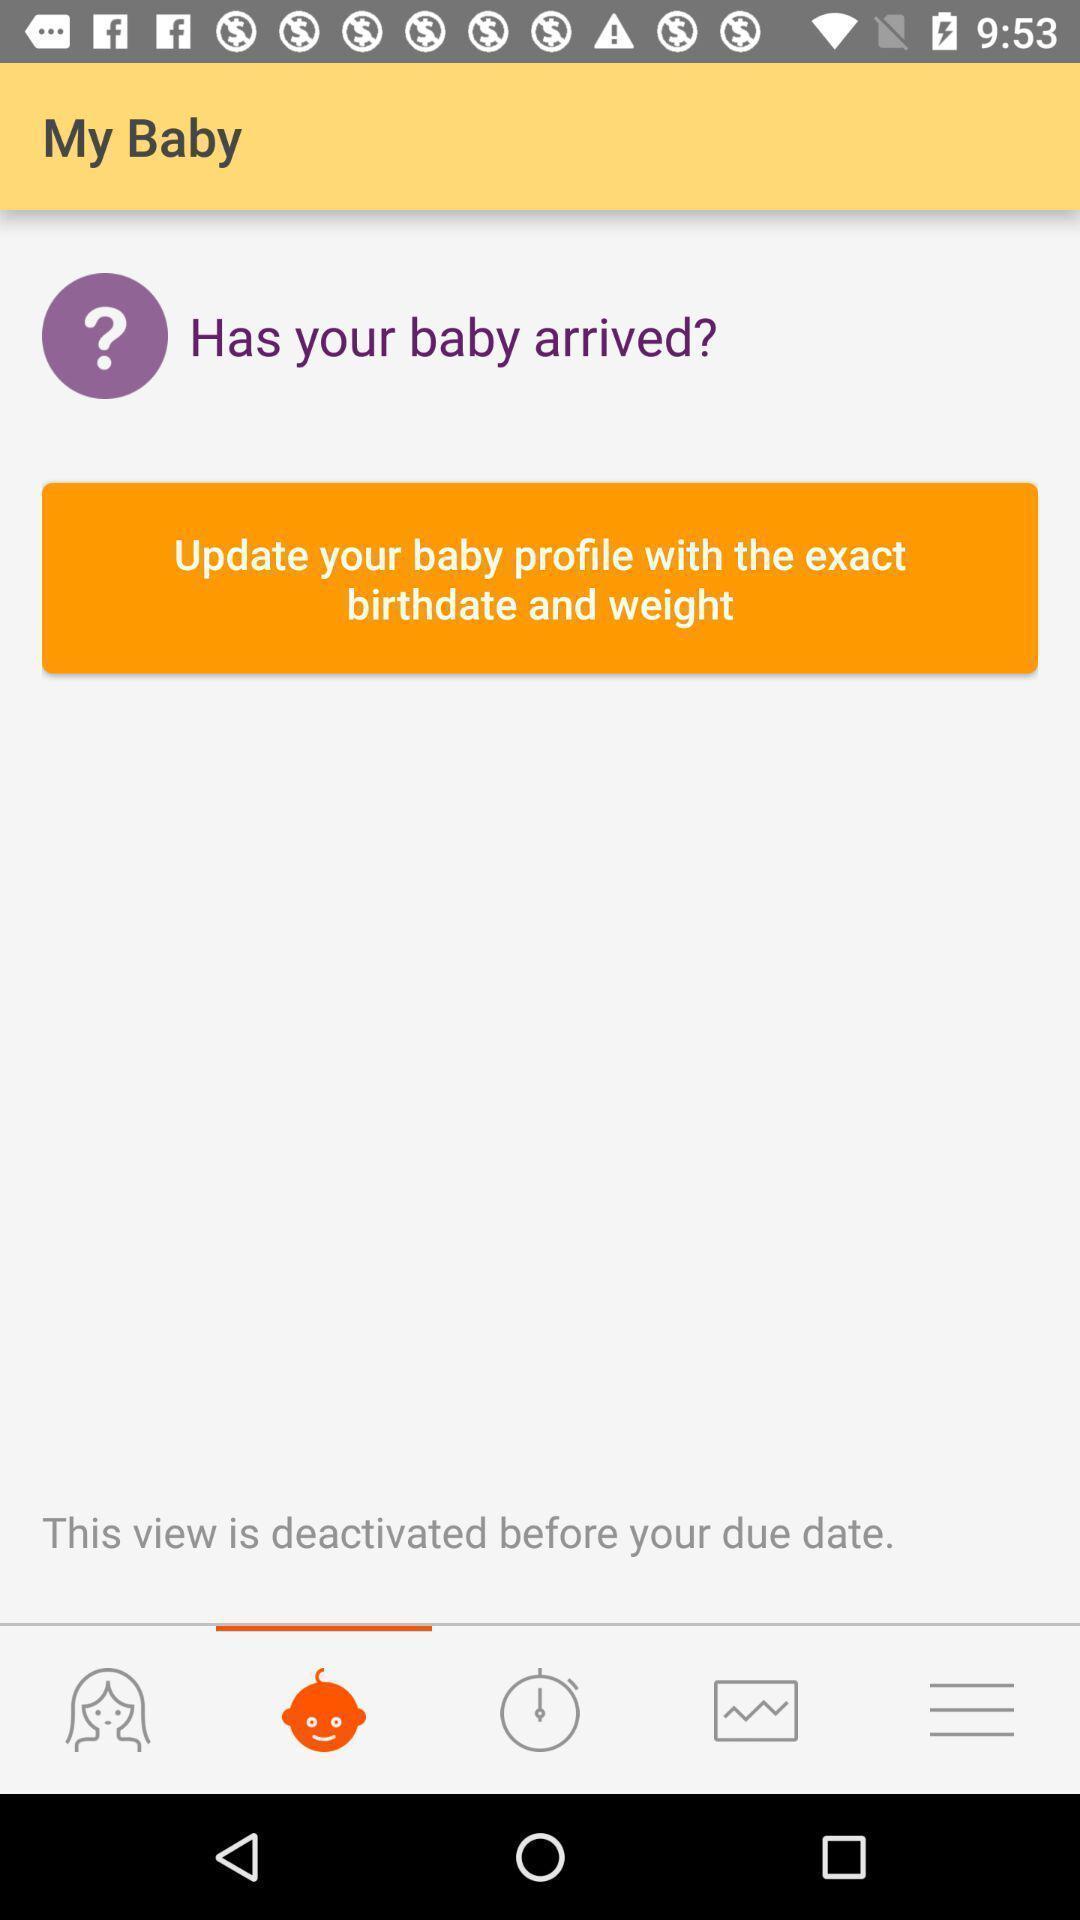What is the overall content of this screenshot? Page showing update profile. 